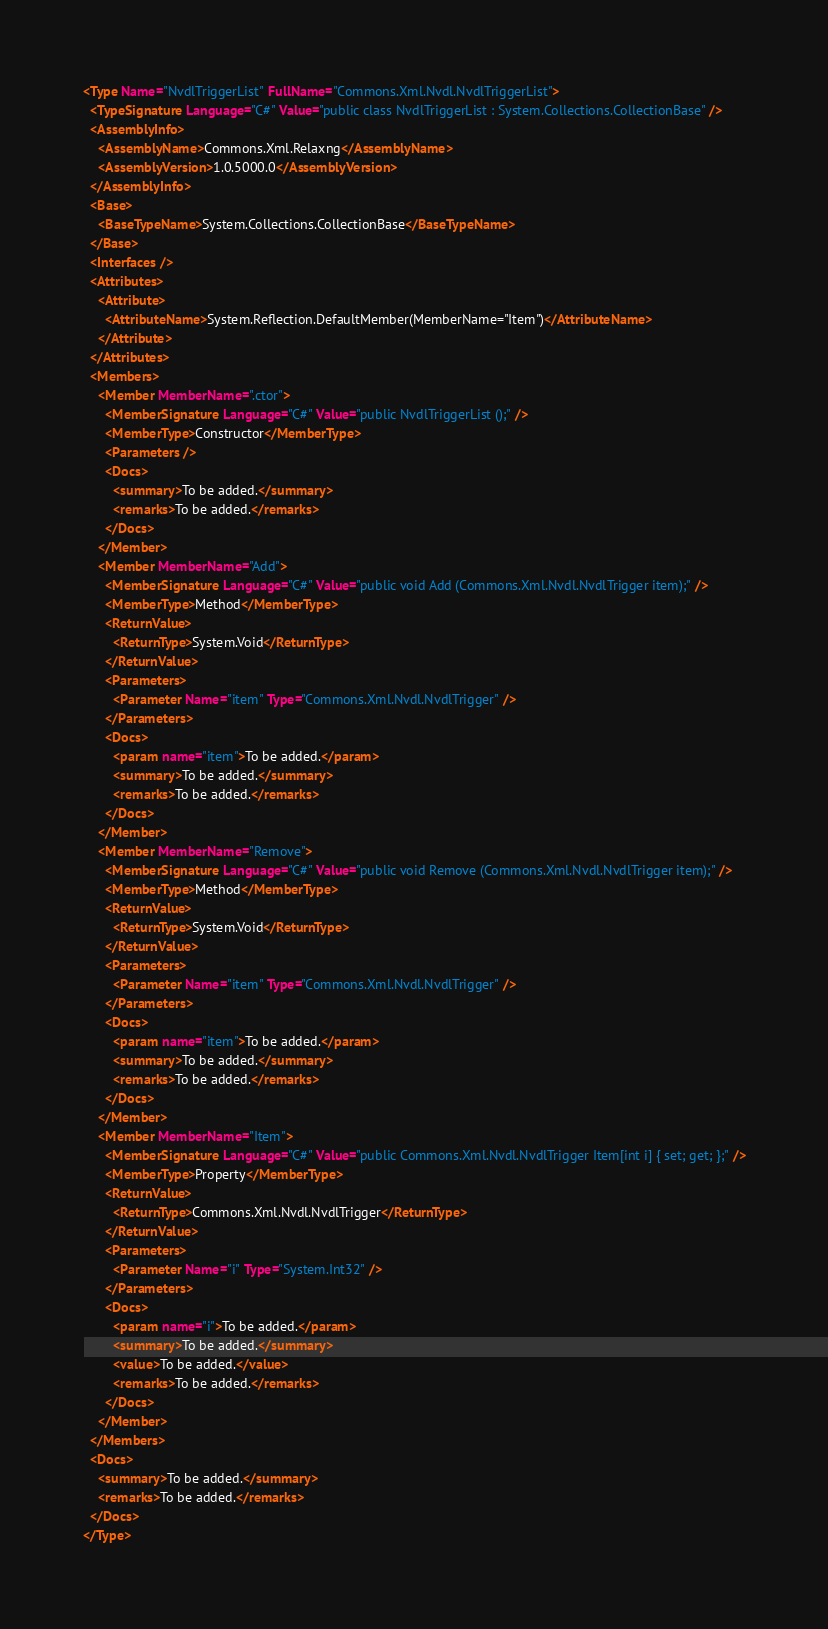<code> <loc_0><loc_0><loc_500><loc_500><_XML_><Type Name="NvdlTriggerList" FullName="Commons.Xml.Nvdl.NvdlTriggerList">
  <TypeSignature Language="C#" Value="public class NvdlTriggerList : System.Collections.CollectionBase" />
  <AssemblyInfo>
    <AssemblyName>Commons.Xml.Relaxng</AssemblyName>
    <AssemblyVersion>1.0.5000.0</AssemblyVersion>
  </AssemblyInfo>
  <Base>
    <BaseTypeName>System.Collections.CollectionBase</BaseTypeName>
  </Base>
  <Interfaces />
  <Attributes>
    <Attribute>
      <AttributeName>System.Reflection.DefaultMember(MemberName="Item")</AttributeName>
    </Attribute>
  </Attributes>
  <Members>
    <Member MemberName=".ctor">
      <MemberSignature Language="C#" Value="public NvdlTriggerList ();" />
      <MemberType>Constructor</MemberType>
      <Parameters />
      <Docs>
        <summary>To be added.</summary>
        <remarks>To be added.</remarks>
      </Docs>
    </Member>
    <Member MemberName="Add">
      <MemberSignature Language="C#" Value="public void Add (Commons.Xml.Nvdl.NvdlTrigger item);" />
      <MemberType>Method</MemberType>
      <ReturnValue>
        <ReturnType>System.Void</ReturnType>
      </ReturnValue>
      <Parameters>
        <Parameter Name="item" Type="Commons.Xml.Nvdl.NvdlTrigger" />
      </Parameters>
      <Docs>
        <param name="item">To be added.</param>
        <summary>To be added.</summary>
        <remarks>To be added.</remarks>
      </Docs>
    </Member>
    <Member MemberName="Remove">
      <MemberSignature Language="C#" Value="public void Remove (Commons.Xml.Nvdl.NvdlTrigger item);" />
      <MemberType>Method</MemberType>
      <ReturnValue>
        <ReturnType>System.Void</ReturnType>
      </ReturnValue>
      <Parameters>
        <Parameter Name="item" Type="Commons.Xml.Nvdl.NvdlTrigger" />
      </Parameters>
      <Docs>
        <param name="item">To be added.</param>
        <summary>To be added.</summary>
        <remarks>To be added.</remarks>
      </Docs>
    </Member>
    <Member MemberName="Item">
      <MemberSignature Language="C#" Value="public Commons.Xml.Nvdl.NvdlTrigger Item[int i] { set; get; };" />
      <MemberType>Property</MemberType>
      <ReturnValue>
        <ReturnType>Commons.Xml.Nvdl.NvdlTrigger</ReturnType>
      </ReturnValue>
      <Parameters>
        <Parameter Name="i" Type="System.Int32" />
      </Parameters>
      <Docs>
        <param name="i">To be added.</param>
        <summary>To be added.</summary>
        <value>To be added.</value>
        <remarks>To be added.</remarks>
      </Docs>
    </Member>
  </Members>
  <Docs>
    <summary>To be added.</summary>
    <remarks>To be added.</remarks>
  </Docs>
</Type>
</code> 